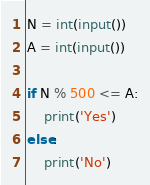Convert code to text. <code><loc_0><loc_0><loc_500><loc_500><_Python_>N = int(input())
A = int(input())

if N % 500 <= A:
	print('Yes')
else:
	print('No')</code> 